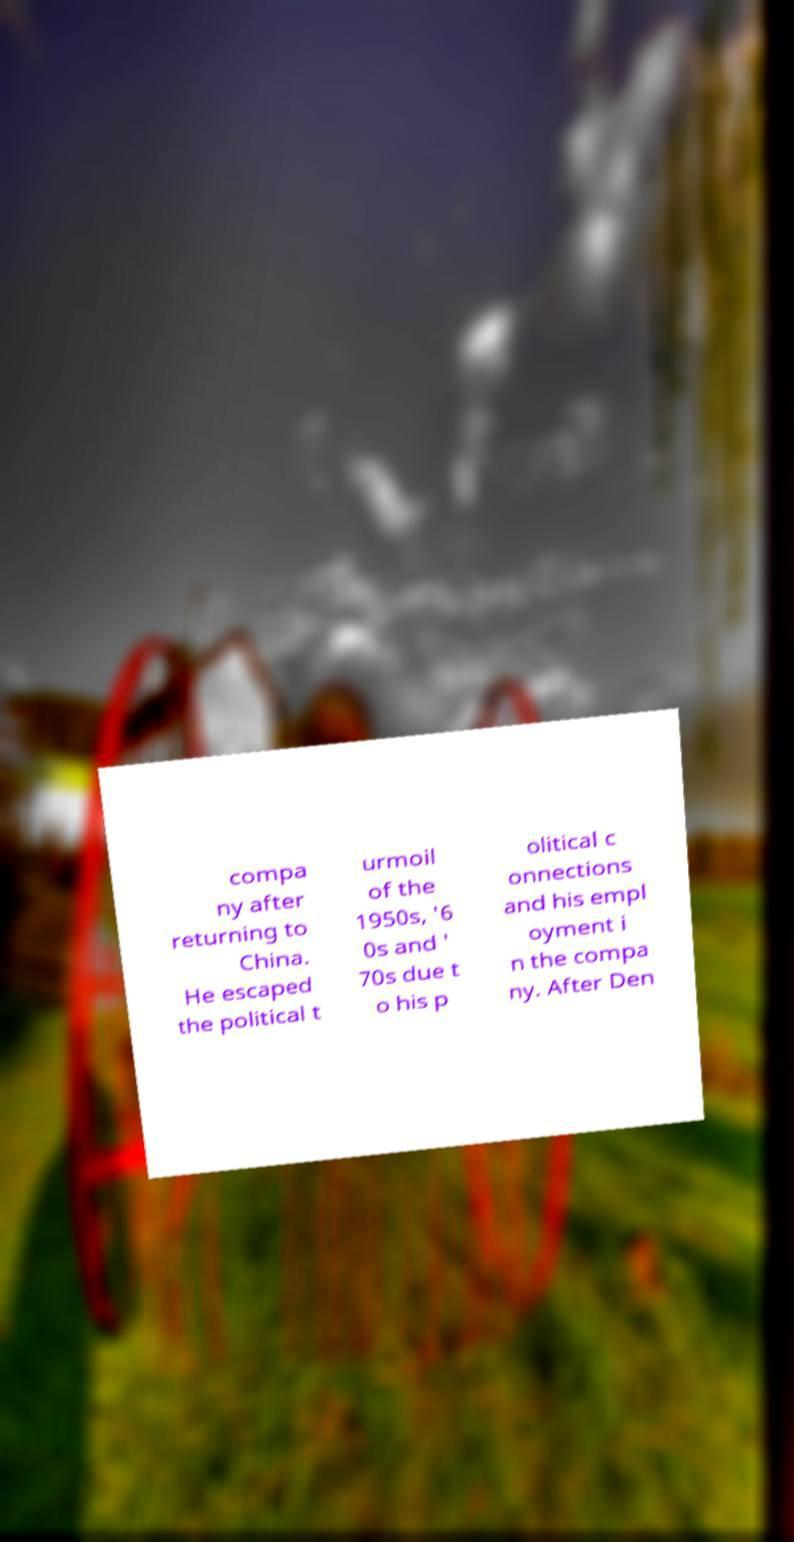There's text embedded in this image that I need extracted. Can you transcribe it verbatim? compa ny after returning to China. He escaped the political t urmoil of the 1950s, '6 0s and ' 70s due t o his p olitical c onnections and his empl oyment i n the compa ny. After Den 